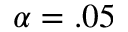Convert formula to latex. <formula><loc_0><loc_0><loc_500><loc_500>\alpha = . 0 5</formula> 